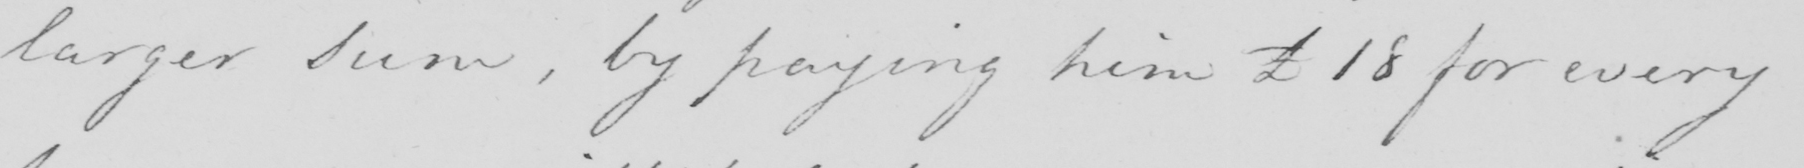What does this handwritten line say? larger Sum , by paying him £18 for every 